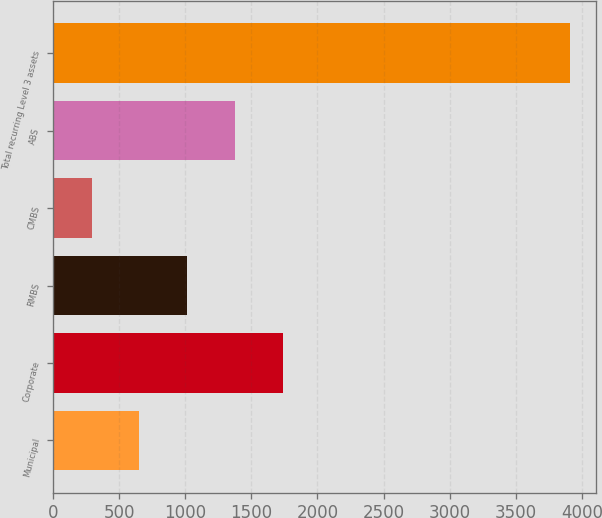Convert chart to OTSL. <chart><loc_0><loc_0><loc_500><loc_500><bar_chart><fcel>Municipal<fcel>Corporate<fcel>RMBS<fcel>CMBS<fcel>ABS<fcel>Total recurring Level 3 assets<nl><fcel>652.9<fcel>1738.6<fcel>1014.8<fcel>291<fcel>1376.7<fcel>3910<nl></chart> 